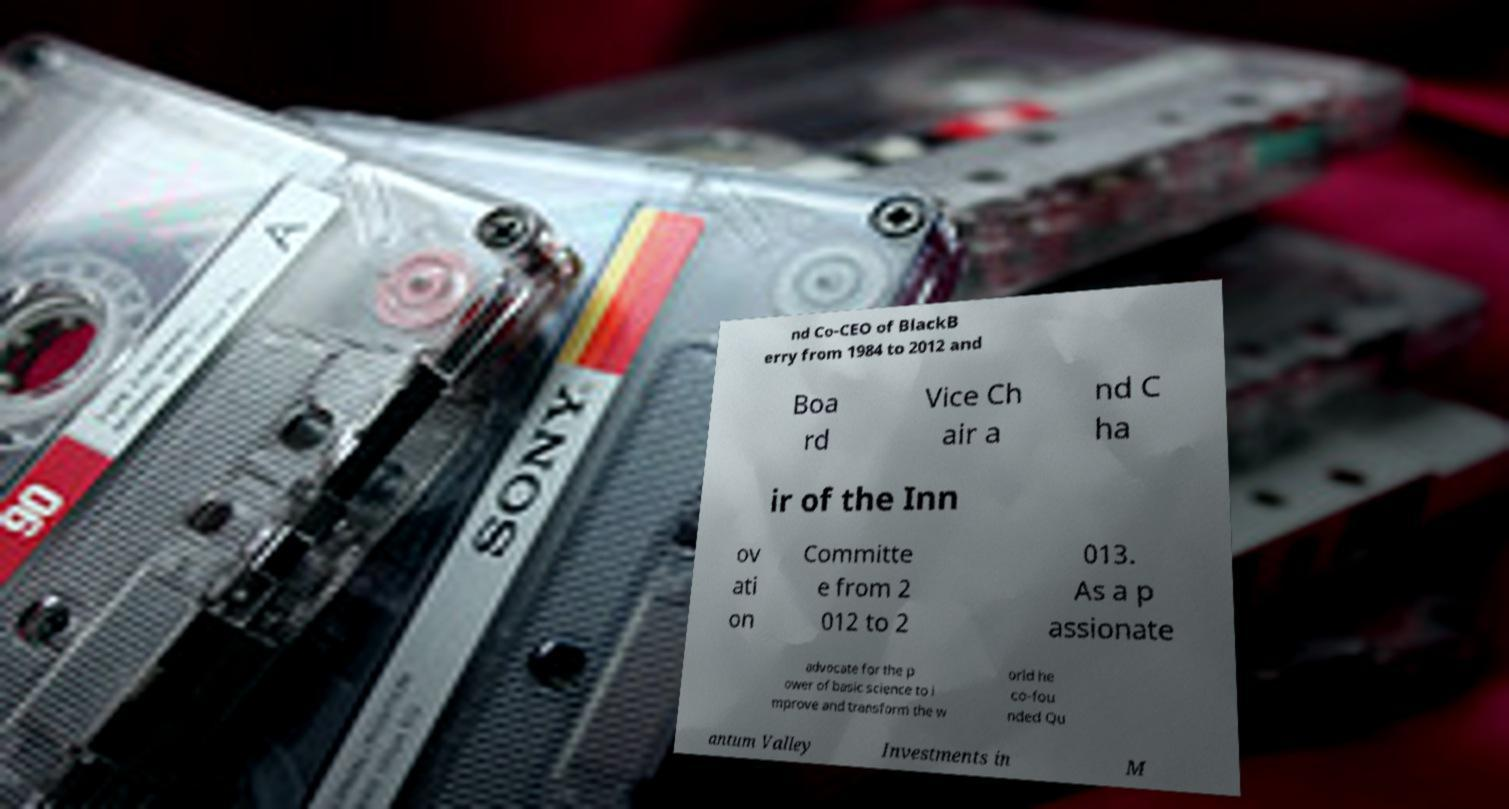Can you read and provide the text displayed in the image?This photo seems to have some interesting text. Can you extract and type it out for me? nd Co-CEO of BlackB erry from 1984 to 2012 and Boa rd Vice Ch air a nd C ha ir of the Inn ov ati on Committe e from 2 012 to 2 013. As a p assionate advocate for the p ower of basic science to i mprove and transform the w orld he co-fou nded Qu antum Valley Investments in M 